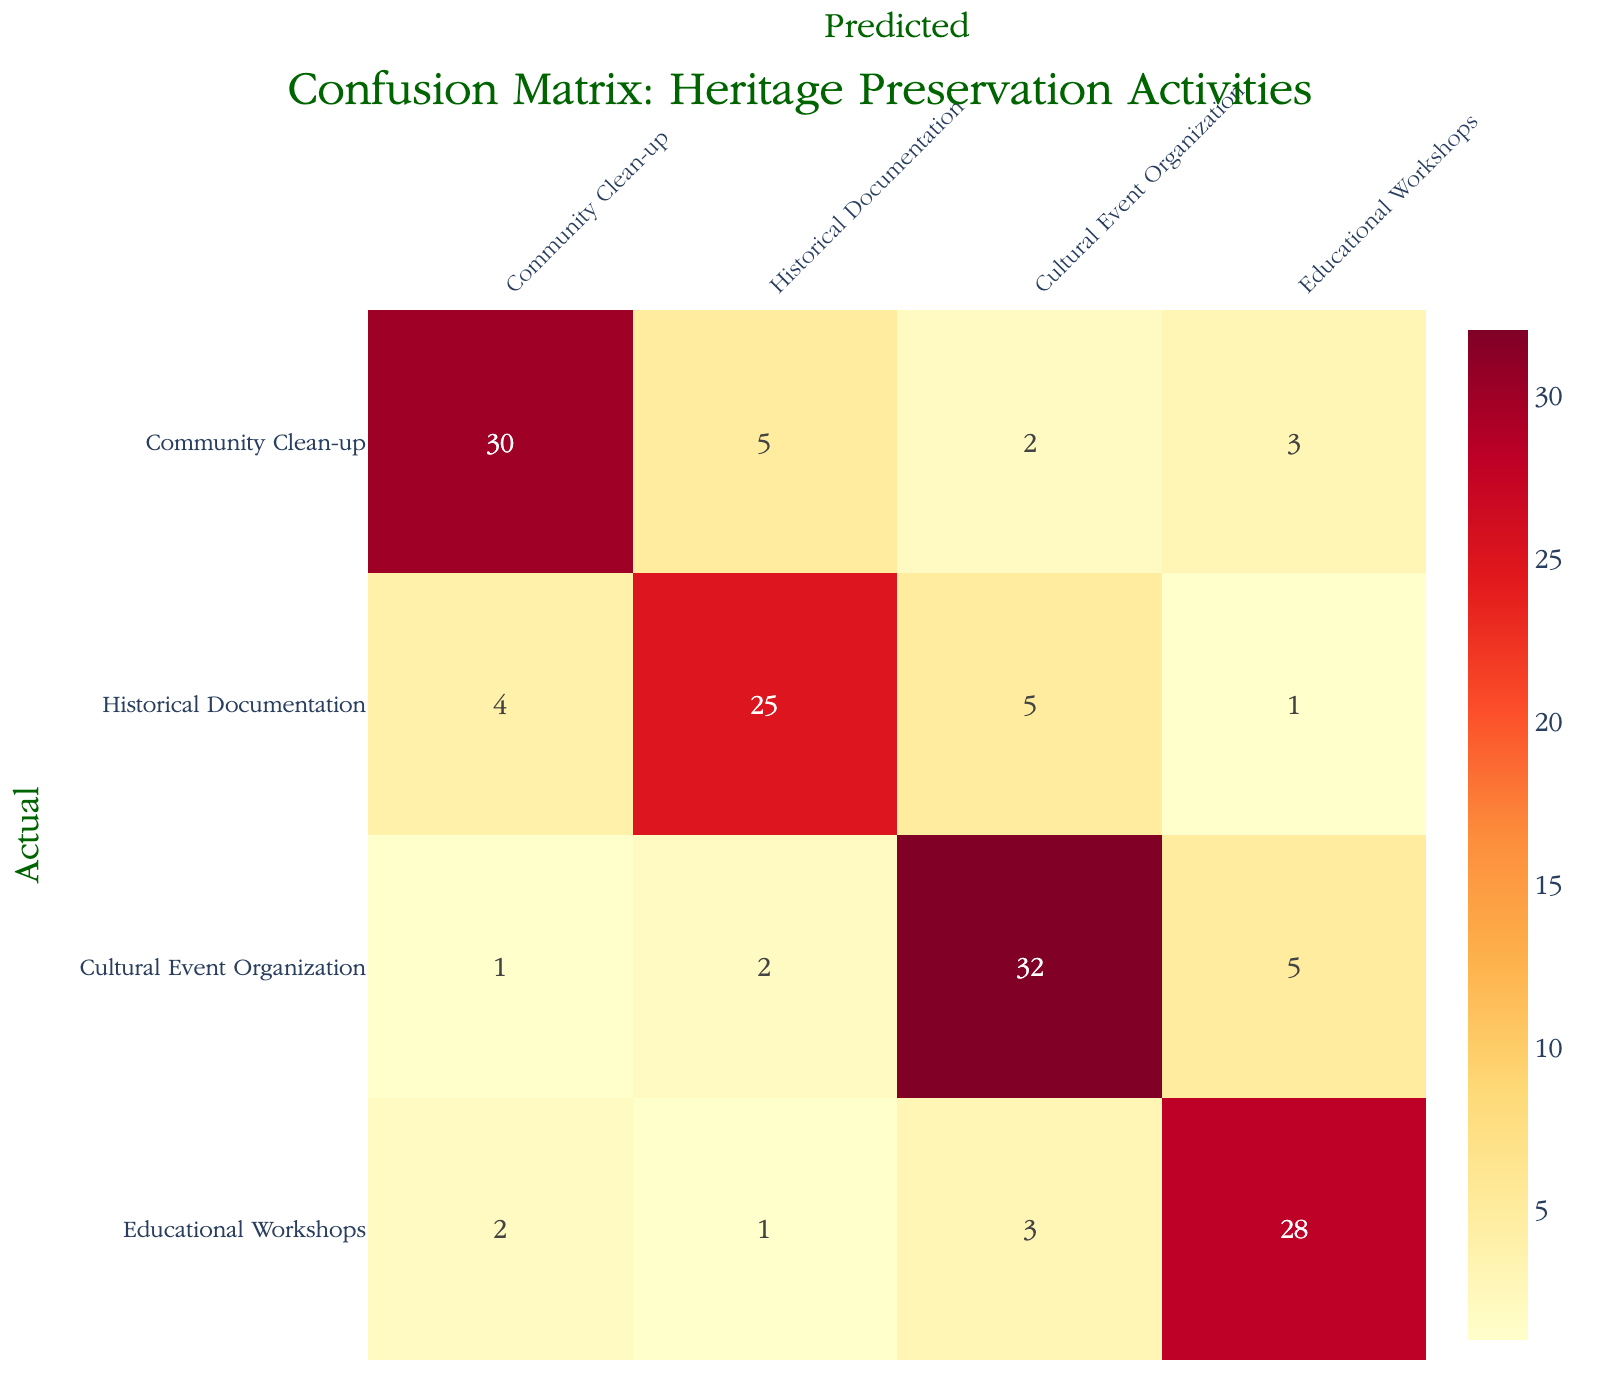What is the total number of "Community Clean-up" activities predicted? In the "Community Clean-up" row, there is one predicted value for each type of volunteer activity. Adding these values gives us the total predicted: 30 (Community Clean-up) + 5 (Historical Documentation) + 2 (Cultural Event Organization) + 3 (Educational Workshops) = 40.
Answer: 40 What is the number of actual "Cultural Event Organization" activities? In the "Cultural Event Organization" row, the actual value reads 32. Therefore, there are 32 activities categorized under "Cultural Event Organization."
Answer: 32 What activity had the highest misclassification? To determine the activity with the highest misclassification, we compare the off-diagonal values in the table for each actual activity type. For "Cultural Event Organization," there are 7 misclassified (1 as Community Clean-up, 2 as Historical Documentation, and 5 as Educational Workshops), which is greater than the misclassifications for the other activities.
Answer: Cultural Event Organization What is the total of all predicted activities for "Historical Documentation"? In the "Historical Documentation" row, the predicted values are as follows: 4 (Community Clean-up) + 25 (Historical Documentation) + 5 (Cultural Event Organization) + 1 (Educational Workshops). When summed, this equals 35.
Answer: 35 Is the number of actual "Educational Workshops" activities greater than the number of actual "Community Clean-up" activities? The actual values for "Educational Workshops" and "Community Clean-up" are 28 and 30, respectively. Since 28 is less than 30, the statement is false.
Answer: No What is the percentage of correctly predicted "Educational Workshops"? The correctly predicted "Educational Workshops" is 28. To calculate the percentage, we use the formula (correct predictions / total predictions) * 100. The total rows provide a total of 34 (2 + 1 + 3 + 28), leading to (28 / 34) * 100 = 82.35%.
Answer: 82.35% What was the most frequently predicted activity overall? By examining the predicted values across all activities, we can find which one appears the most. The predicted activity with the highest count is "Historical Documentation" with 25 instances.
Answer: Historical Documentation 